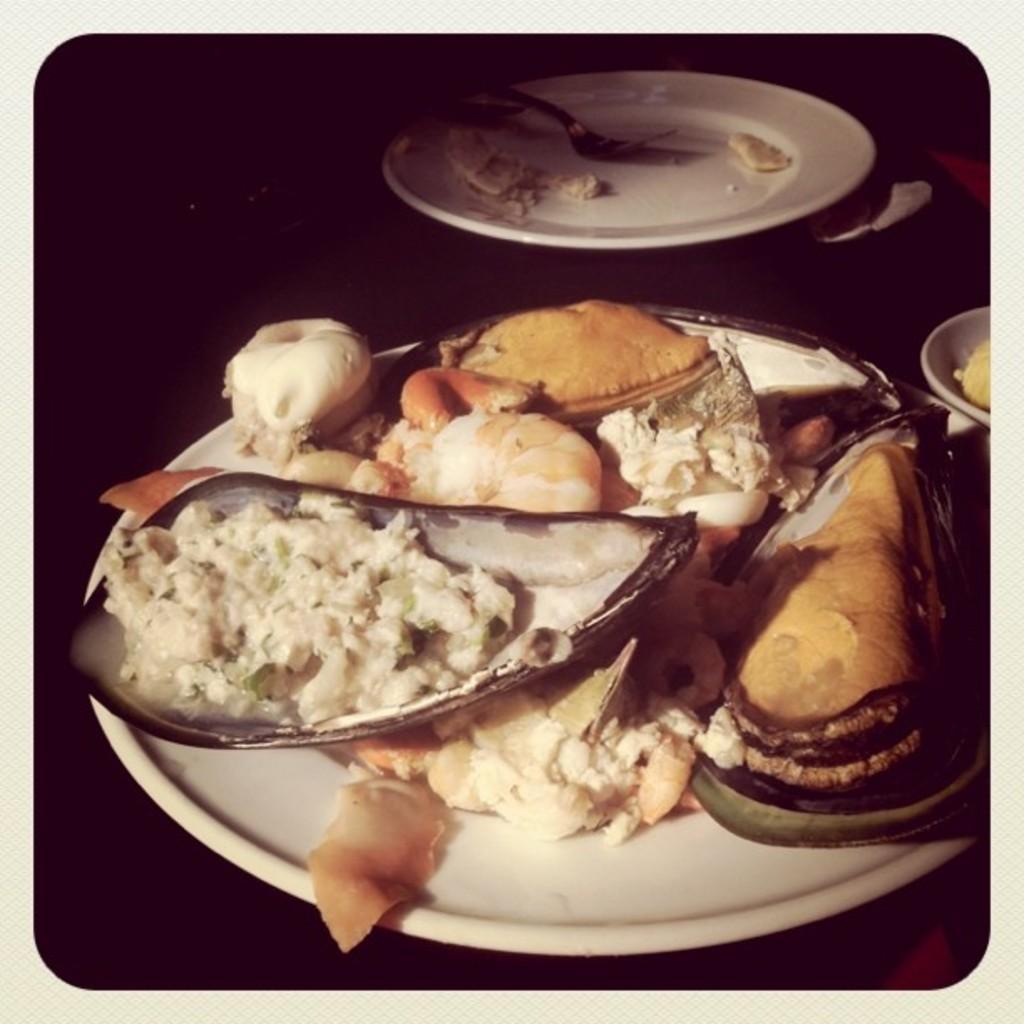Please provide a concise description of this image. In this picture we can see planets, there is some food present in this plate, we can see a fork in this plate, there is a dark background. 